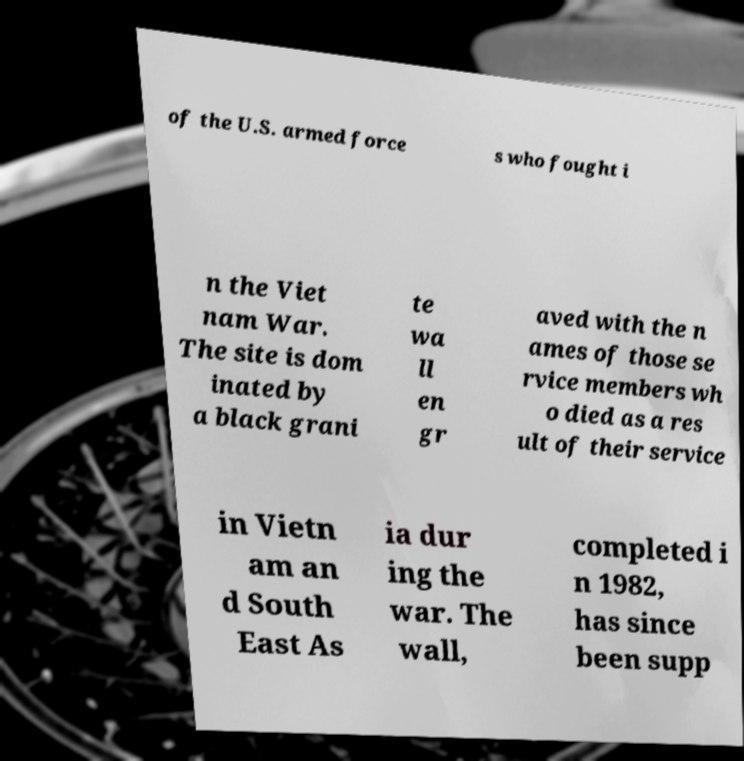Please read and relay the text visible in this image. What does it say? of the U.S. armed force s who fought i n the Viet nam War. The site is dom inated by a black grani te wa ll en gr aved with the n ames of those se rvice members wh o died as a res ult of their service in Vietn am an d South East As ia dur ing the war. The wall, completed i n 1982, has since been supp 